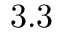Convert formula to latex. <formula><loc_0><loc_0><loc_500><loc_500>3 . 3</formula> 